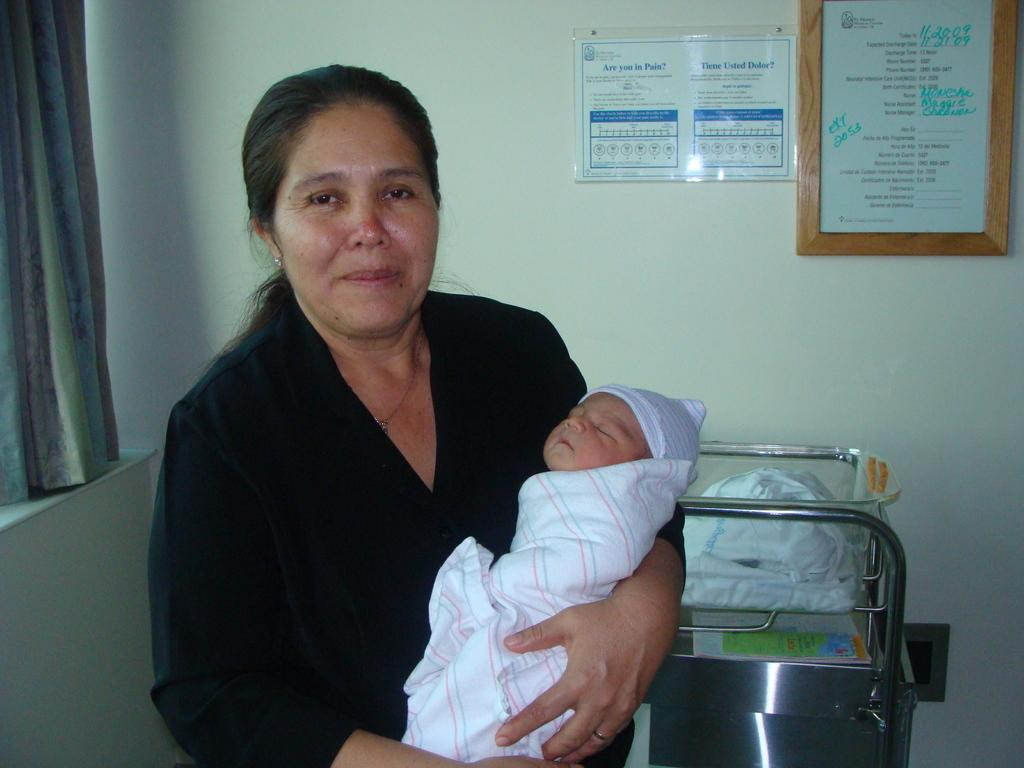<image>
Share a concise interpretation of the image provided. The lady is holding a new baby that was born in November. 